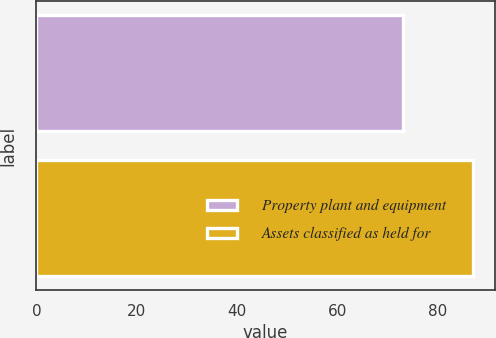Convert chart to OTSL. <chart><loc_0><loc_0><loc_500><loc_500><bar_chart><fcel>Property plant and equipment<fcel>Assets classified as held for<nl><fcel>73<fcel>87<nl></chart> 